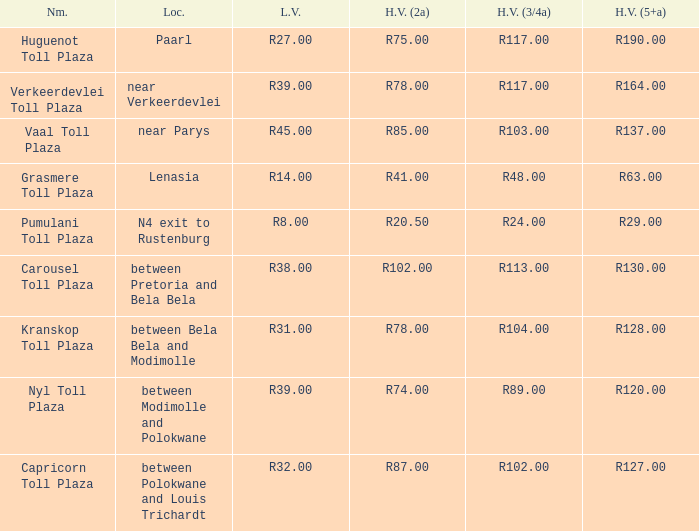I'm looking to parse the entire table for insights. Could you assist me with that? {'header': ['Nm.', 'Loc.', 'L.V.', 'H.V. (2a)', 'H.V. (3/4a)', 'H.V. (5+a)'], 'rows': [['Huguenot Toll Plaza', 'Paarl', 'R27.00', 'R75.00', 'R117.00', 'R190.00'], ['Verkeerdevlei Toll Plaza', 'near Verkeerdevlei', 'R39.00', 'R78.00', 'R117.00', 'R164.00'], ['Vaal Toll Plaza', 'near Parys', 'R45.00', 'R85.00', 'R103.00', 'R137.00'], ['Grasmere Toll Plaza', 'Lenasia', 'R14.00', 'R41.00', 'R48.00', 'R63.00'], ['Pumulani Toll Plaza', 'N4 exit to Rustenburg', 'R8.00', 'R20.50', 'R24.00', 'R29.00'], ['Carousel Toll Plaza', 'between Pretoria and Bela Bela', 'R38.00', 'R102.00', 'R113.00', 'R130.00'], ['Kranskop Toll Plaza', 'between Bela Bela and Modimolle', 'R31.00', 'R78.00', 'R104.00', 'R128.00'], ['Nyl Toll Plaza', 'between Modimolle and Polokwane', 'R39.00', 'R74.00', 'R89.00', 'R120.00'], ['Capricorn Toll Plaza', 'between Polokwane and Louis Trichardt', 'R32.00', 'R87.00', 'R102.00', 'R127.00']]} 50? Pumulani Toll Plaza. 